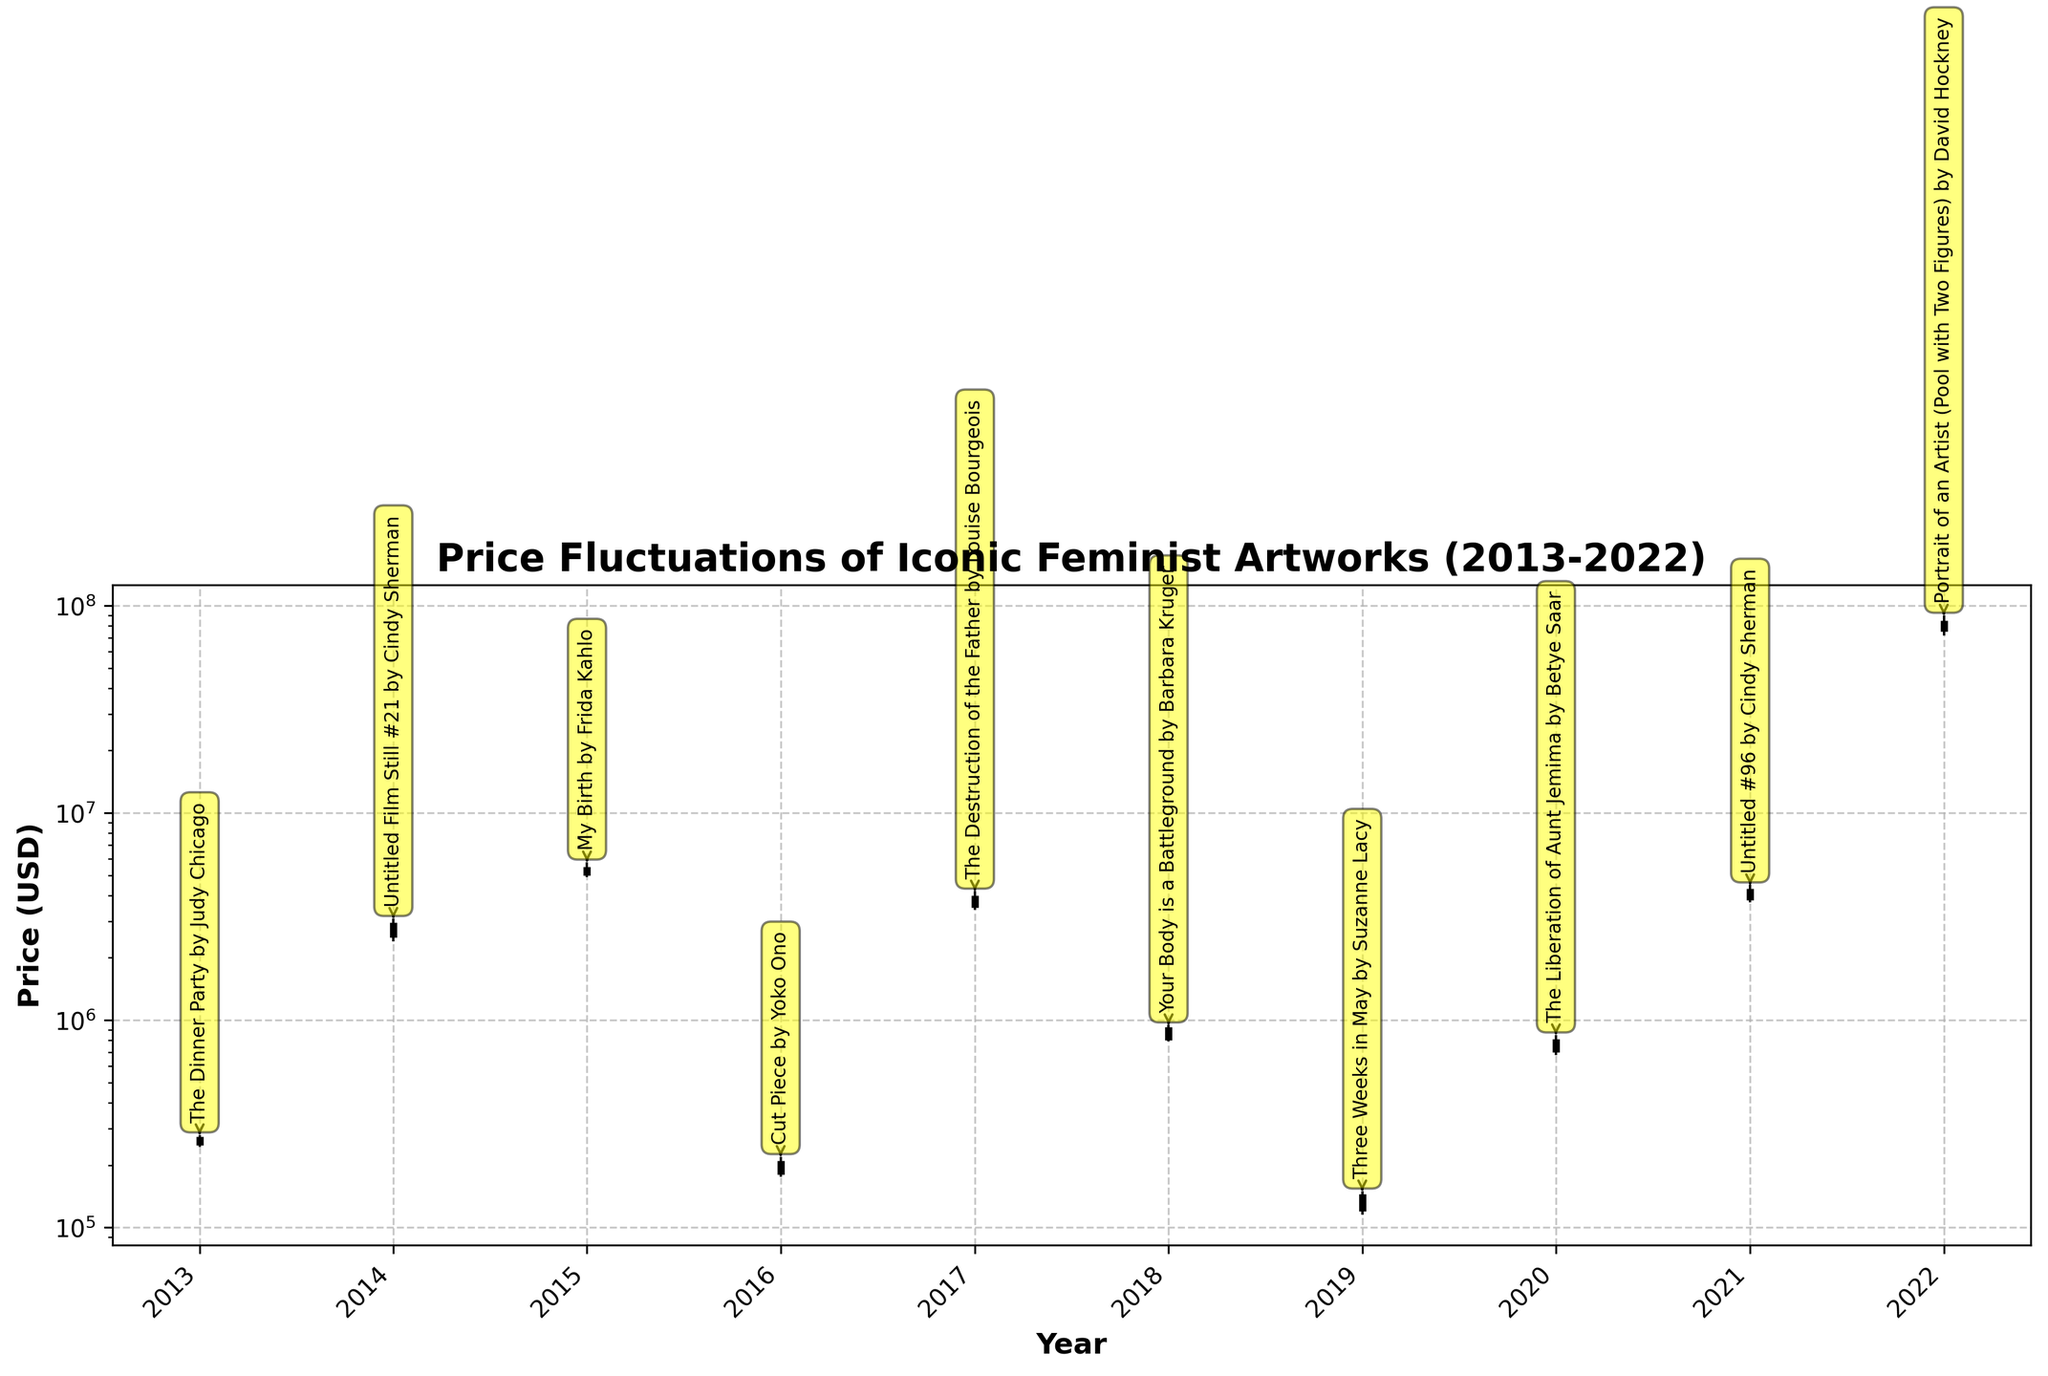What is the title of the chart? The title is located at the top of the figure, providing a summary of the chart's content. It reads "Price Fluctuations of Iconic Feminist Artworks (2013-2022)".
Answer: Price Fluctuations of Iconic Feminist Artworks (2013-2022) How many artworks are plotted on the chart? Each artwork corresponds to an individual set of values on different years, and the data lists 10 different artworks. Hence, the chart plots 10 artworks.
Answer: 10 artworks Which artwork had the highest closing price and in which year? Looking at the highest end of the closing price lines, "Portrait of an Artist (Pool with Two Figures) by David Hockney" in 2022 has the highest closing price.
Answer: Portrait of an Artist (Pool with Two Figures) by David Hockney, 2022 What is the range of the artwork "Untitled Film Still #21 by Cindy Sherman" in 2014? The range is calculated by subtracting the lowest price (Low) from the highest price (High). For 2014, this is 3,100,000 - 2,400,000.
Answer: 700,000 Which year shows the lowest opening price for any artwork, and which artwork is it? By inspecting the lowest extremity of the opening prices, "Cut Piece by Yoko Ono" in 2016 exhibits the lowest opening price.
Answer: 2016, Cut Piece by Yoko Ono Did "My Birth by Frida Kahlo" in 2015 close higher than it opened? Comparing the open and close prices for "My Birth by Frida Kahlo" in 2015, where the open price was 5,000,000 and the close price was 5,500,000, shows it closed higher.
Answer: Yes Compare the opening prices of "Untitled Film Still #21 by Cindy Sherman" in 2014 and "Untitled #96 by Cindy Sherman" in 2021. Which is higher? Comparing the values, "Untitled Film Still #21 by Cindy Sherman" in 2014 opened at 2,500,000, whereas "Untitled #96 by Cindy Sherman" in 2021 opened at 3,800,000.
Answer: Untitled #96 by Cindy Sherman, 2021 What was the closing price of "The Dinner Party by Judy Chicago" in 2013 and how does it compare to "The Liberation of Aunt Jemima by Betye Saar" in 2020? "The Dinner Party by Judy Chicago" closed at 275,000 in 2013, while "The Liberation of Aunt Jemima by Betye Saar" closed at 810,000 in 2020.
Answer: The Liberation of Aunt Jemima by Betye Saar in 2020 had a higher closing price Which artwork shows the largest spread (difference between high and low prices) over the period, and what is the value of this spread? By comparing the differences between high and low prices, "Portrait of an Artist (Pool with Two Figures) by David Hockney" in 2022 shows the largest spread: 90,000,000 - 72,000,000.
Answer: 18,000,000 